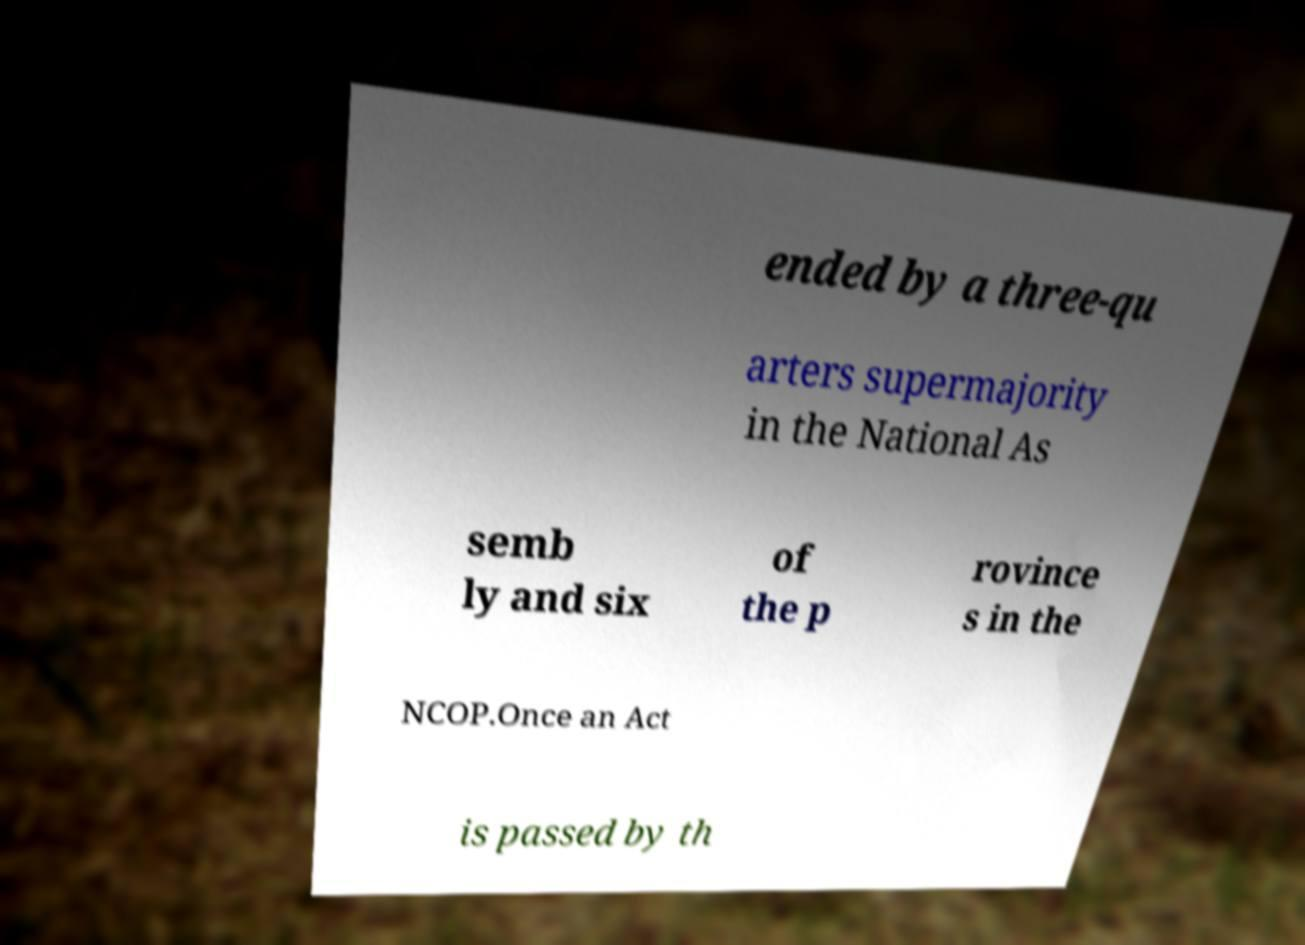Please identify and transcribe the text found in this image. ended by a three-qu arters supermajority in the National As semb ly and six of the p rovince s in the NCOP.Once an Act is passed by th 